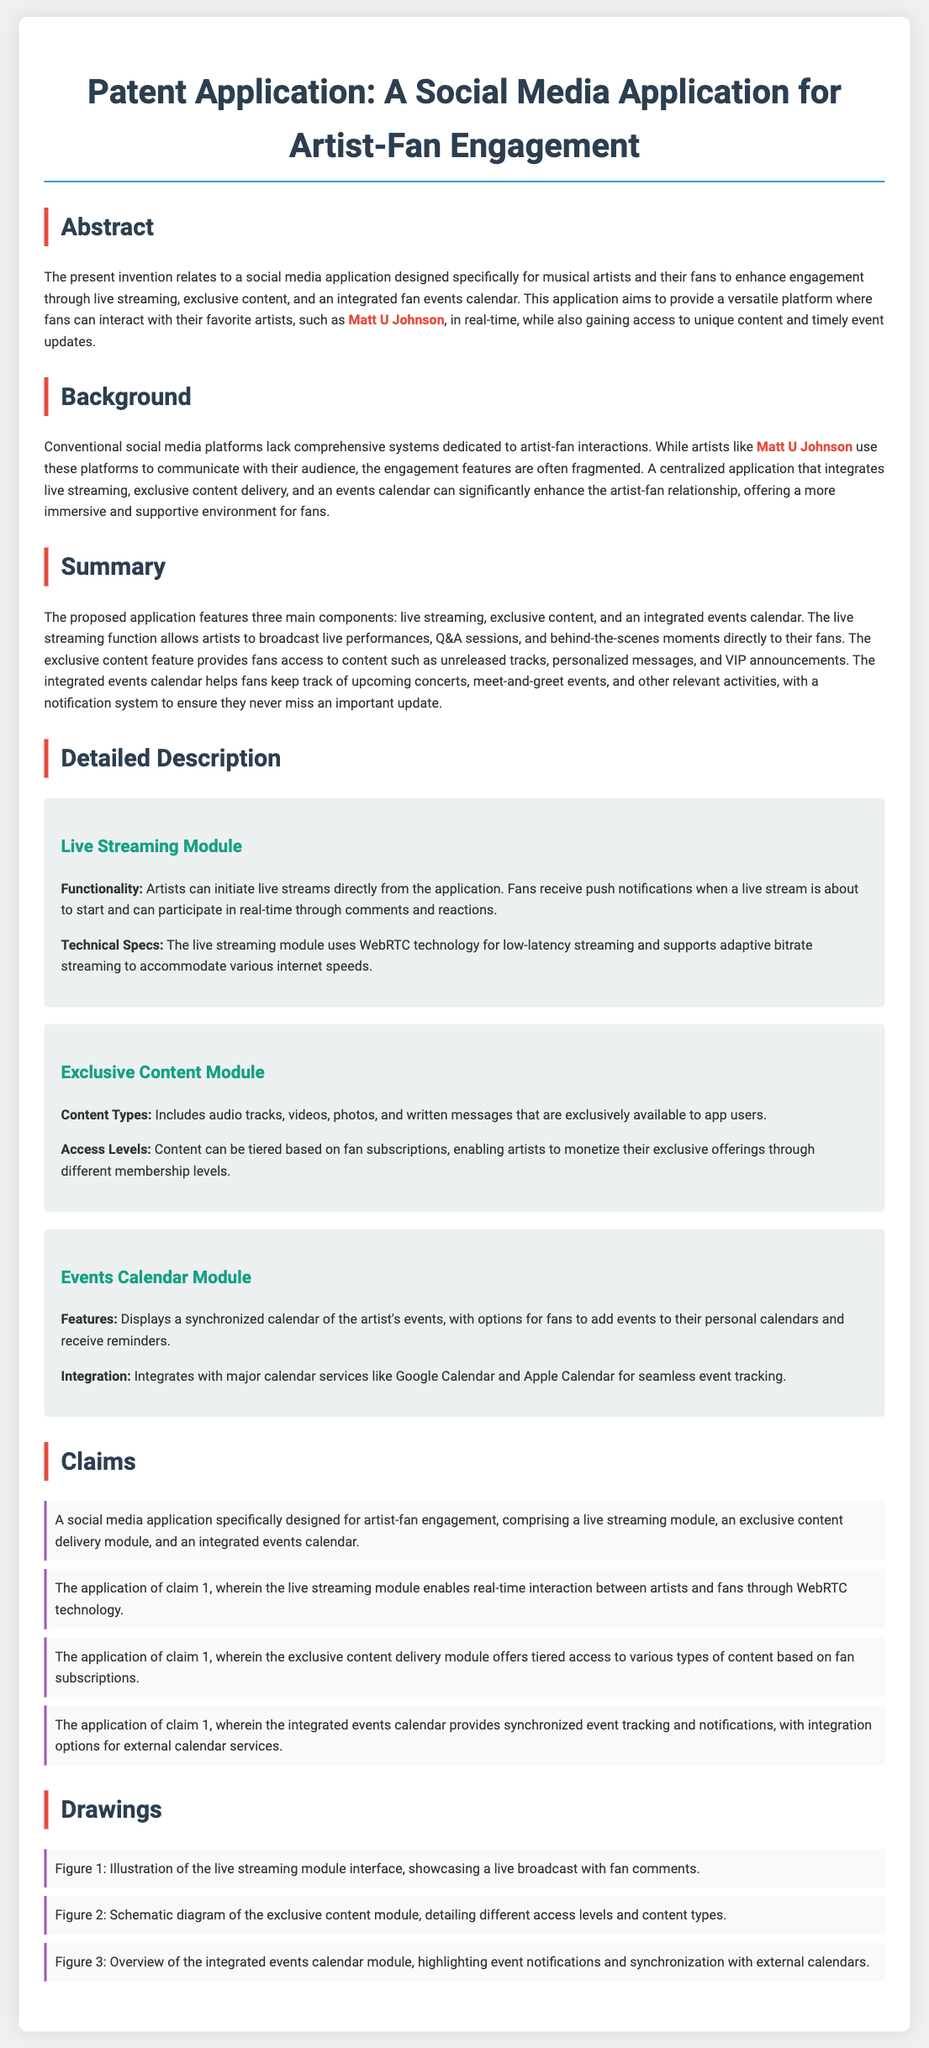What is the main purpose of the application? The main purpose of the application is to enhance engagement between musical artists and their fans.
Answer: Enhance engagement Who is specifically mentioned as an artist in the document? The document specifically mentions Matt U Johnson as an artist.
Answer: Matt U Johnson What technology does the live streaming module use? The live streaming module uses WebRTC technology for low-latency streaming.
Answer: WebRTC What type of access does the exclusive content module provide? The exclusive content module provides tiered access based on fan subscriptions.
Answer: Tiered access How many claims are listed in the document? The document lists four claims related to the application.
Answer: Four What is the title of the second module described in the detailed description? The title of the second module is the Exclusive Content Module.
Answer: Exclusive Content Module Which module allows real-time interaction? The live streaming module allows real-time interaction between artists and fans.
Answer: Live streaming module What feature does the events calendar include? The events calendar includes synchronized event tracking and notifications.
Answer: Synchronized event tracking 